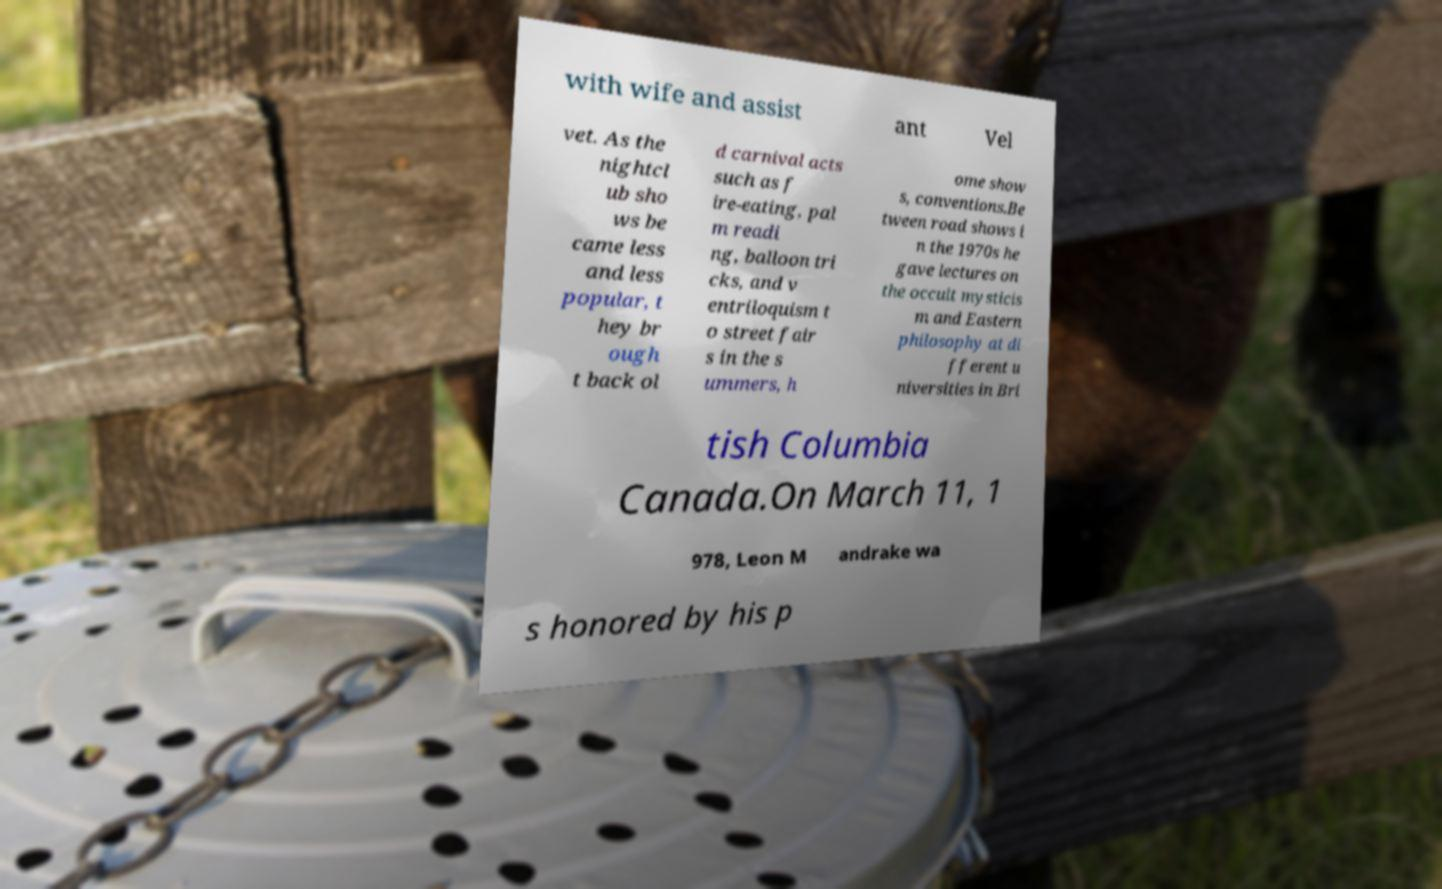I need the written content from this picture converted into text. Can you do that? with wife and assist ant Vel vet. As the nightcl ub sho ws be came less and less popular, t hey br ough t back ol d carnival acts such as f ire-eating, pal m readi ng, balloon tri cks, and v entriloquism t o street fair s in the s ummers, h ome show s, conventions.Be tween road shows i n the 1970s he gave lectures on the occult mysticis m and Eastern philosophy at di fferent u niversities in Bri tish Columbia Canada.On March 11, 1 978, Leon M andrake wa s honored by his p 